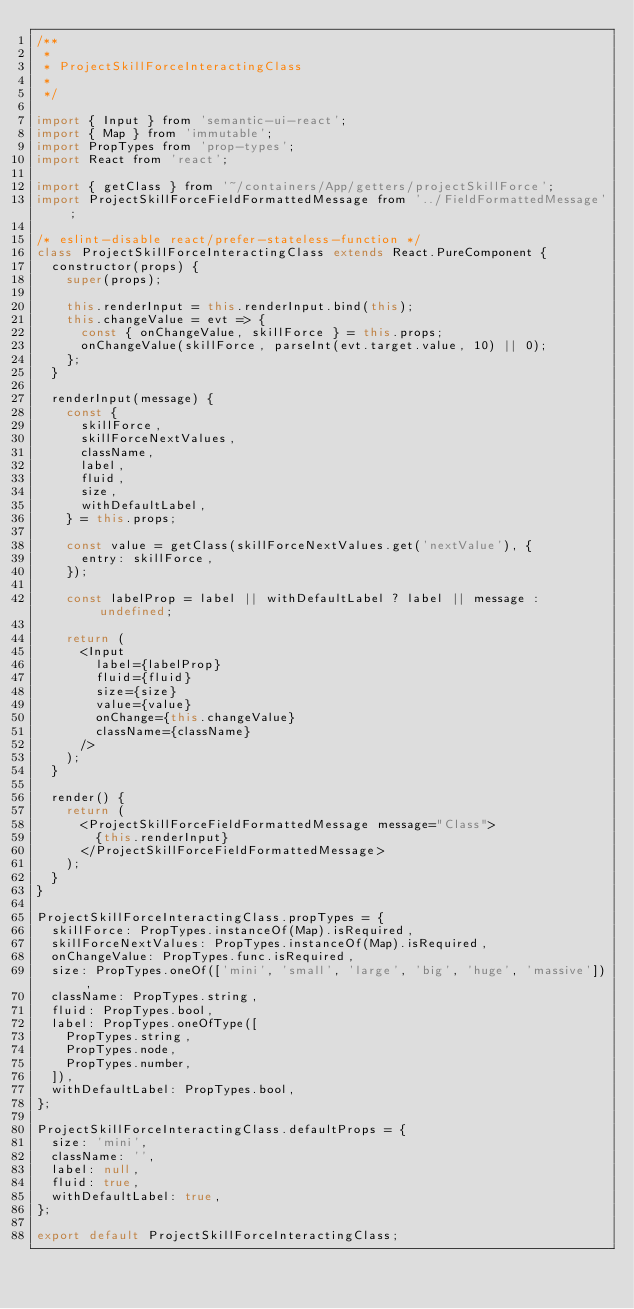Convert code to text. <code><loc_0><loc_0><loc_500><loc_500><_JavaScript_>/**
 *
 * ProjectSkillForceInteractingClass
 *
 */

import { Input } from 'semantic-ui-react';
import { Map } from 'immutable';
import PropTypes from 'prop-types';
import React from 'react';

import { getClass } from '~/containers/App/getters/projectSkillForce';
import ProjectSkillForceFieldFormattedMessage from '../FieldFormattedMessage';

/* eslint-disable react/prefer-stateless-function */
class ProjectSkillForceInteractingClass extends React.PureComponent {
  constructor(props) {
    super(props);

    this.renderInput = this.renderInput.bind(this);
    this.changeValue = evt => {
      const { onChangeValue, skillForce } = this.props;
      onChangeValue(skillForce, parseInt(evt.target.value, 10) || 0);
    };
  }

  renderInput(message) {
    const {
      skillForce,
      skillForceNextValues,
      className,
      label,
      fluid,
      size,
      withDefaultLabel,
    } = this.props;

    const value = getClass(skillForceNextValues.get('nextValue'), {
      entry: skillForce,
    });

    const labelProp = label || withDefaultLabel ? label || message : undefined;

    return (
      <Input
        label={labelProp}
        fluid={fluid}
        size={size}
        value={value}
        onChange={this.changeValue}
        className={className}
      />
    );
  }

  render() {
    return (
      <ProjectSkillForceFieldFormattedMessage message="Class">
        {this.renderInput}
      </ProjectSkillForceFieldFormattedMessage>
    );
  }
}

ProjectSkillForceInteractingClass.propTypes = {
  skillForce: PropTypes.instanceOf(Map).isRequired,
  skillForceNextValues: PropTypes.instanceOf(Map).isRequired,
  onChangeValue: PropTypes.func.isRequired,
  size: PropTypes.oneOf(['mini', 'small', 'large', 'big', 'huge', 'massive']),
  className: PropTypes.string,
  fluid: PropTypes.bool,
  label: PropTypes.oneOfType([
    PropTypes.string,
    PropTypes.node,
    PropTypes.number,
  ]),
  withDefaultLabel: PropTypes.bool,
};

ProjectSkillForceInteractingClass.defaultProps = {
  size: 'mini',
  className: '',
  label: null,
  fluid: true,
  withDefaultLabel: true,
};

export default ProjectSkillForceInteractingClass;
</code> 